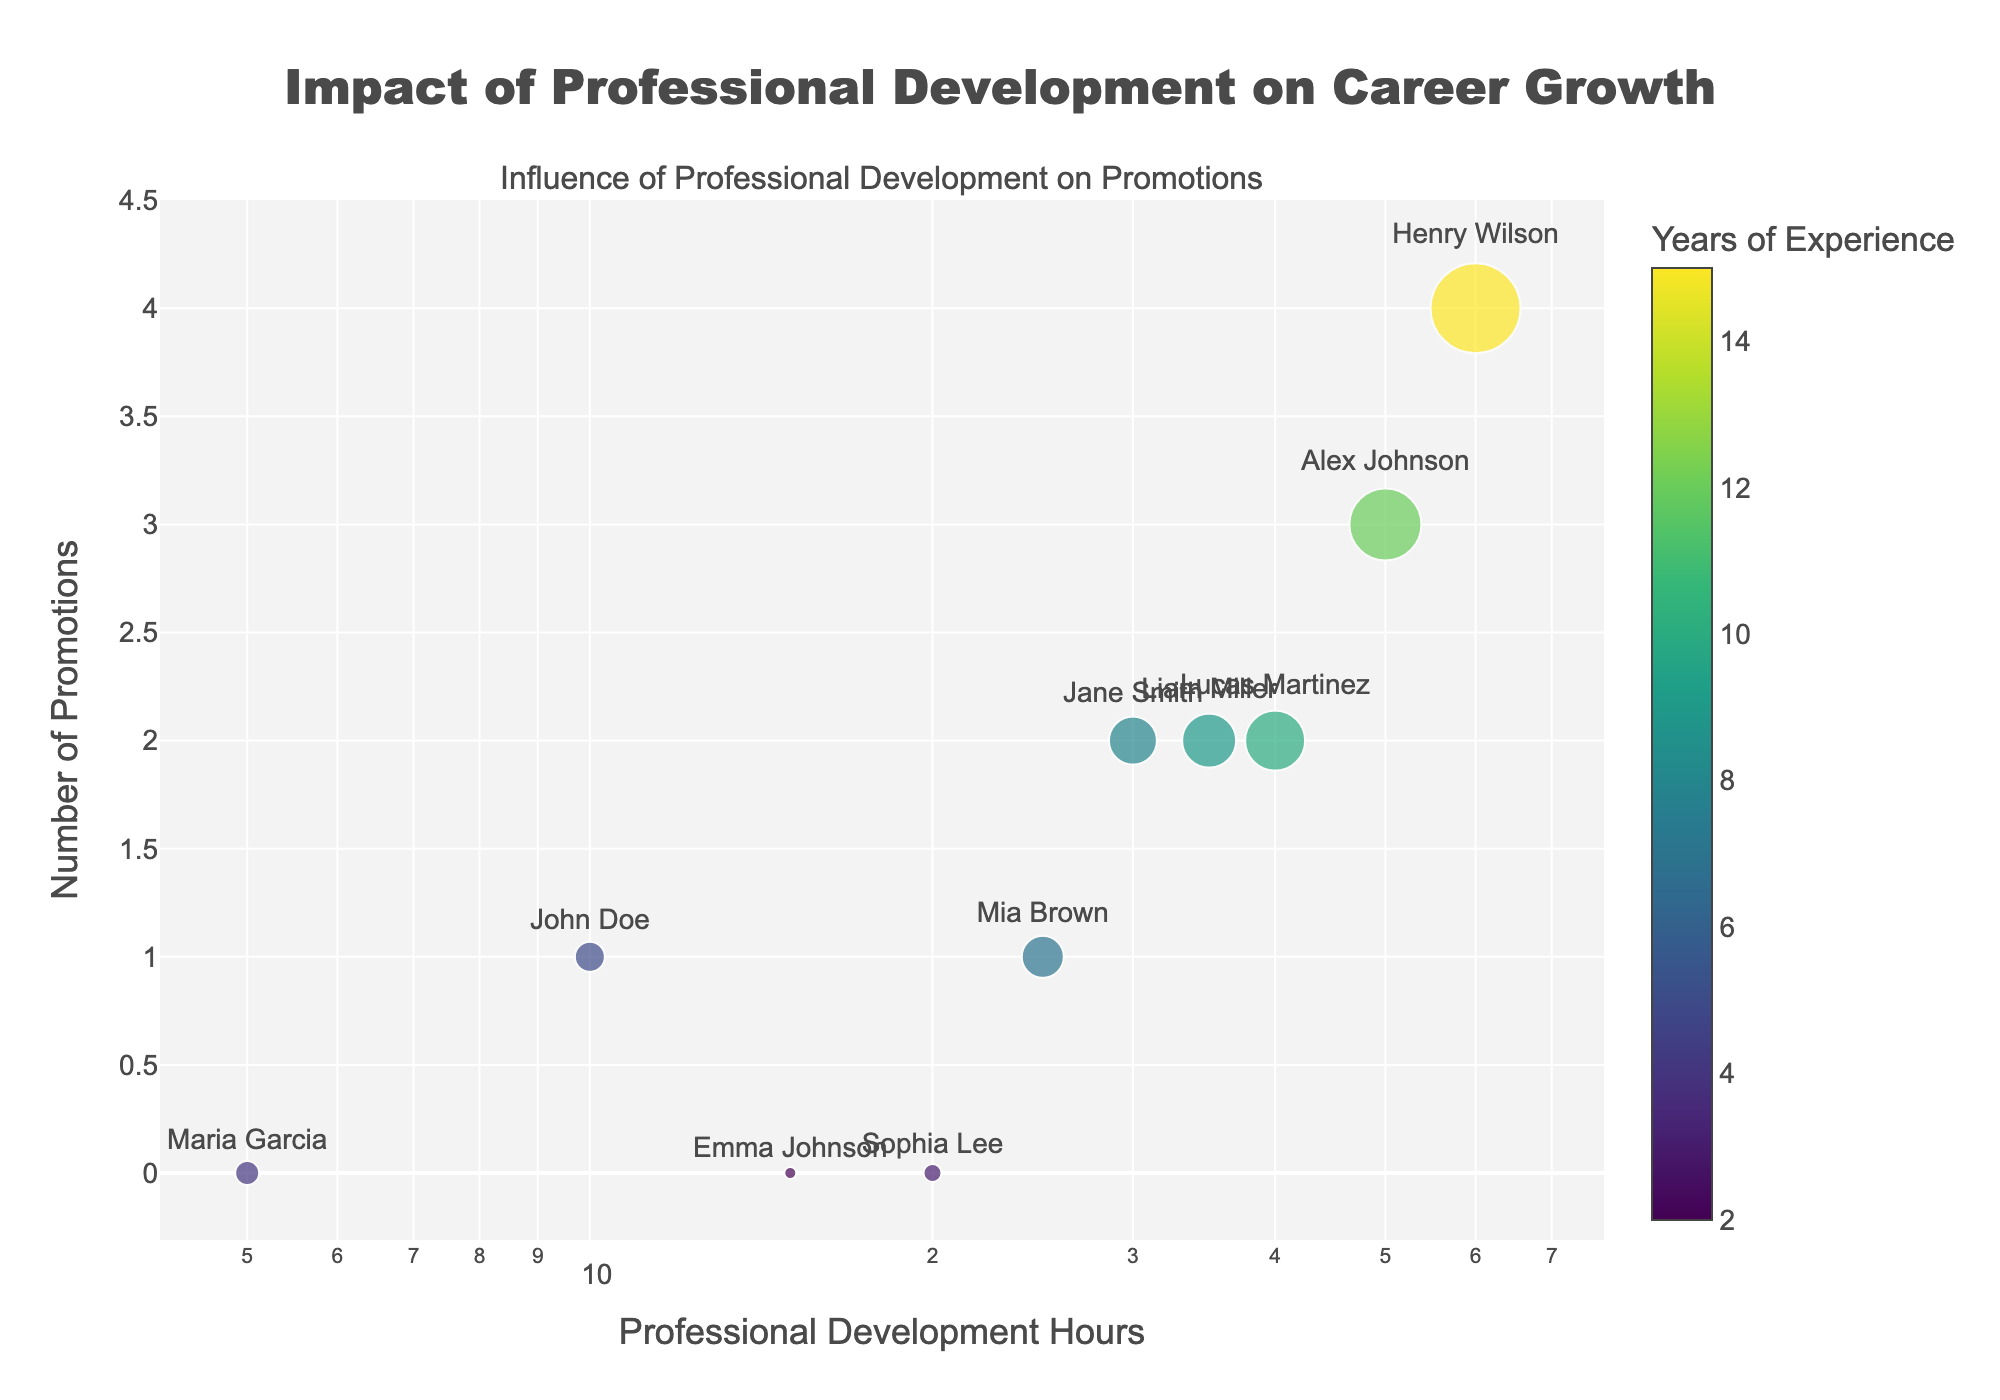What is the title of the scatter plot? The title of the scatter plot is provided at the top of the figure.
Answer: Impact of Professional Development on Career Growth How many employees have zero promotions? To find this, look for data points on the scatter plot where the y-value (Number of Promotions) is zero.
Answer: 3 Who has the highest number of promotions, and how many promotions did they receive? Look for the data point with the highest y-value (Number of Promotions) and refer to the hover text to find the employee's name.
Answer: Henry Wilson, 4 promotions Which employee has the least professional development hours and how many hours did they complete? Look for the data point farthest to the left on the x-axis (Professional Development Hours) and refer to the hover text to find the employee's name and development hours.
Answer: Maria Garcia, 5 hours Are there any employees with equivalent professional development hours but different numbers of promotions? Compare the x-values of data points and check if multiple points share the same x-value but different y-values.
Answer: Yes, Liam Miller and Lucas Martinez both have 35 hours but different promotions (2 vs 2) What is the range of years of experience for employees who haven't been promoted at all? Look at the data points where the y-value (Number of Promotions) is zero and examine the hover text for the range in years of experience.
Answer: 2 to 4 years How many employees have more than 20 years of experience? The hover text on each data point shows the years of experience for each employee. Check if any points mention more than 20 years.
Answer: 0 Who has more promotions, Lucas Martinez or Jane Smith, and by how many? Compare the y-values (Number of Promotions) for these two employees by referring to their data points and hover text.
Answer: Jane Smith by 1 promotion (2 vs 2) What relationship can be inferred between professional development hours and number of promotions? Generally observe the trend of how data points are clustered and whether an increase in x-values (Professional Development Hours) impacts y-values (Number of Promotions).
Answer: Generally, more professional development hours correlate with higher promotions Do employees with the same number of professional development hours always have the same years of experience? Check multiple data points with equivalent x-values (Professional Development Hours) and compare their years of experience mentioned in the color scale and hover text.
Answer: No 